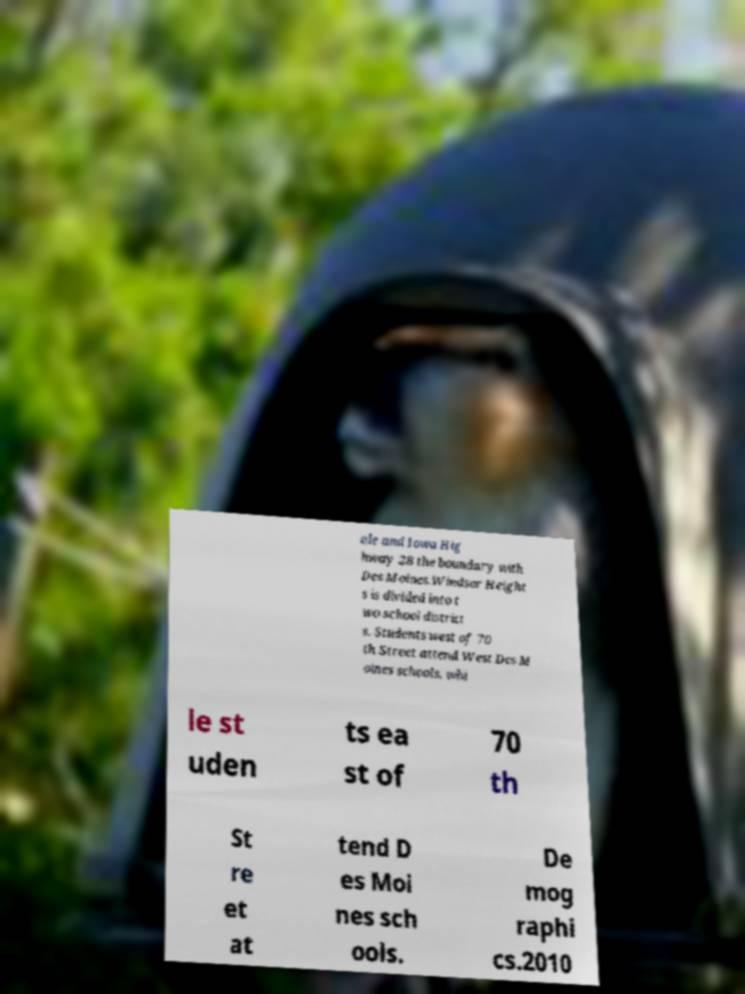There's text embedded in this image that I need extracted. Can you transcribe it verbatim? ale and Iowa Hig hway 28 the boundary with Des Moines.Windsor Height s is divided into t wo school district s. Students west of 70 th Street attend West Des M oines schools, whi le st uden ts ea st of 70 th St re et at tend D es Moi nes sch ools. De mog raphi cs.2010 